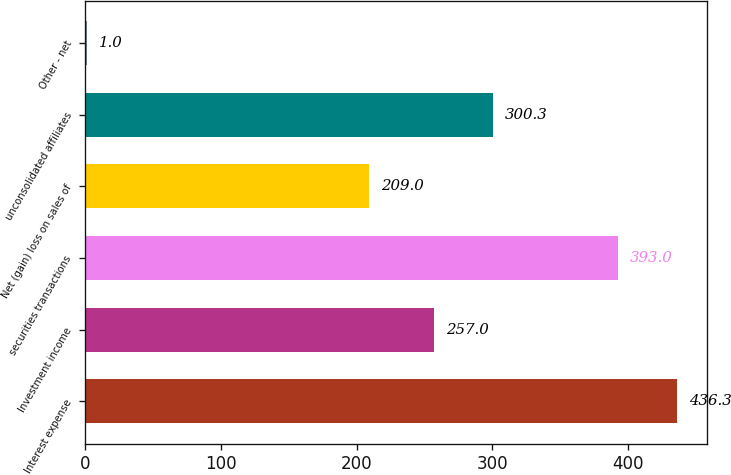Convert chart to OTSL. <chart><loc_0><loc_0><loc_500><loc_500><bar_chart><fcel>Interest expense<fcel>Investment income<fcel>securities transactions<fcel>Net (gain) loss on sales of<fcel>unconsolidated affiliates<fcel>Other - net<nl><fcel>436.3<fcel>257<fcel>393<fcel>209<fcel>300.3<fcel>1<nl></chart> 